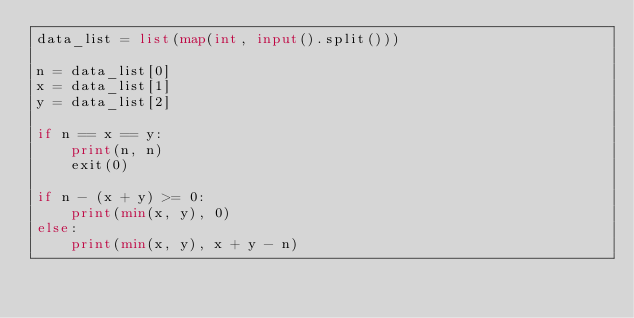<code> <loc_0><loc_0><loc_500><loc_500><_Python_>data_list = list(map(int, input().split()))

n = data_list[0]
x = data_list[1]
y = data_list[2]

if n == x == y:
    print(n, n)
    exit(0)

if n - (x + y) >= 0:
    print(min(x, y), 0)
else:
    print(min(x, y), x + y - n)
</code> 